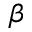Convert formula to latex. <formula><loc_0><loc_0><loc_500><loc_500>\beta</formula> 